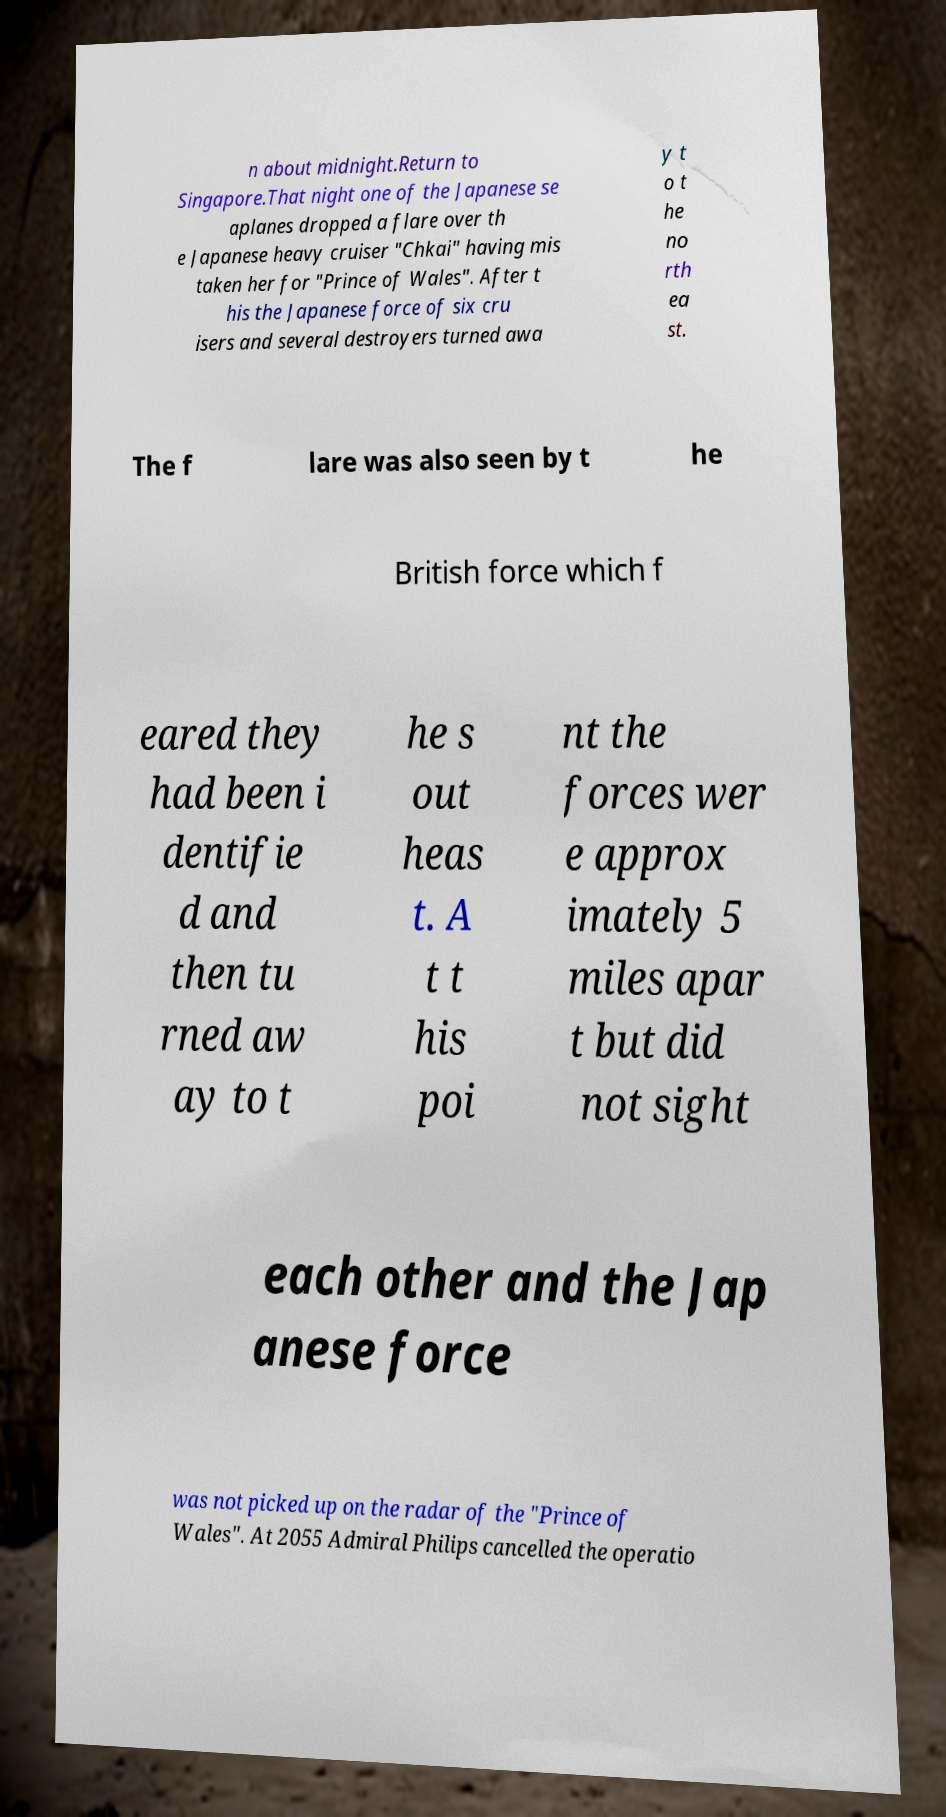What messages or text are displayed in this image? I need them in a readable, typed format. n about midnight.Return to Singapore.That night one of the Japanese se aplanes dropped a flare over th e Japanese heavy cruiser "Chkai" having mis taken her for "Prince of Wales". After t his the Japanese force of six cru isers and several destroyers turned awa y t o t he no rth ea st. The f lare was also seen by t he British force which f eared they had been i dentifie d and then tu rned aw ay to t he s out heas t. A t t his poi nt the forces wer e approx imately 5 miles apar t but did not sight each other and the Jap anese force was not picked up on the radar of the "Prince of Wales". At 2055 Admiral Philips cancelled the operatio 